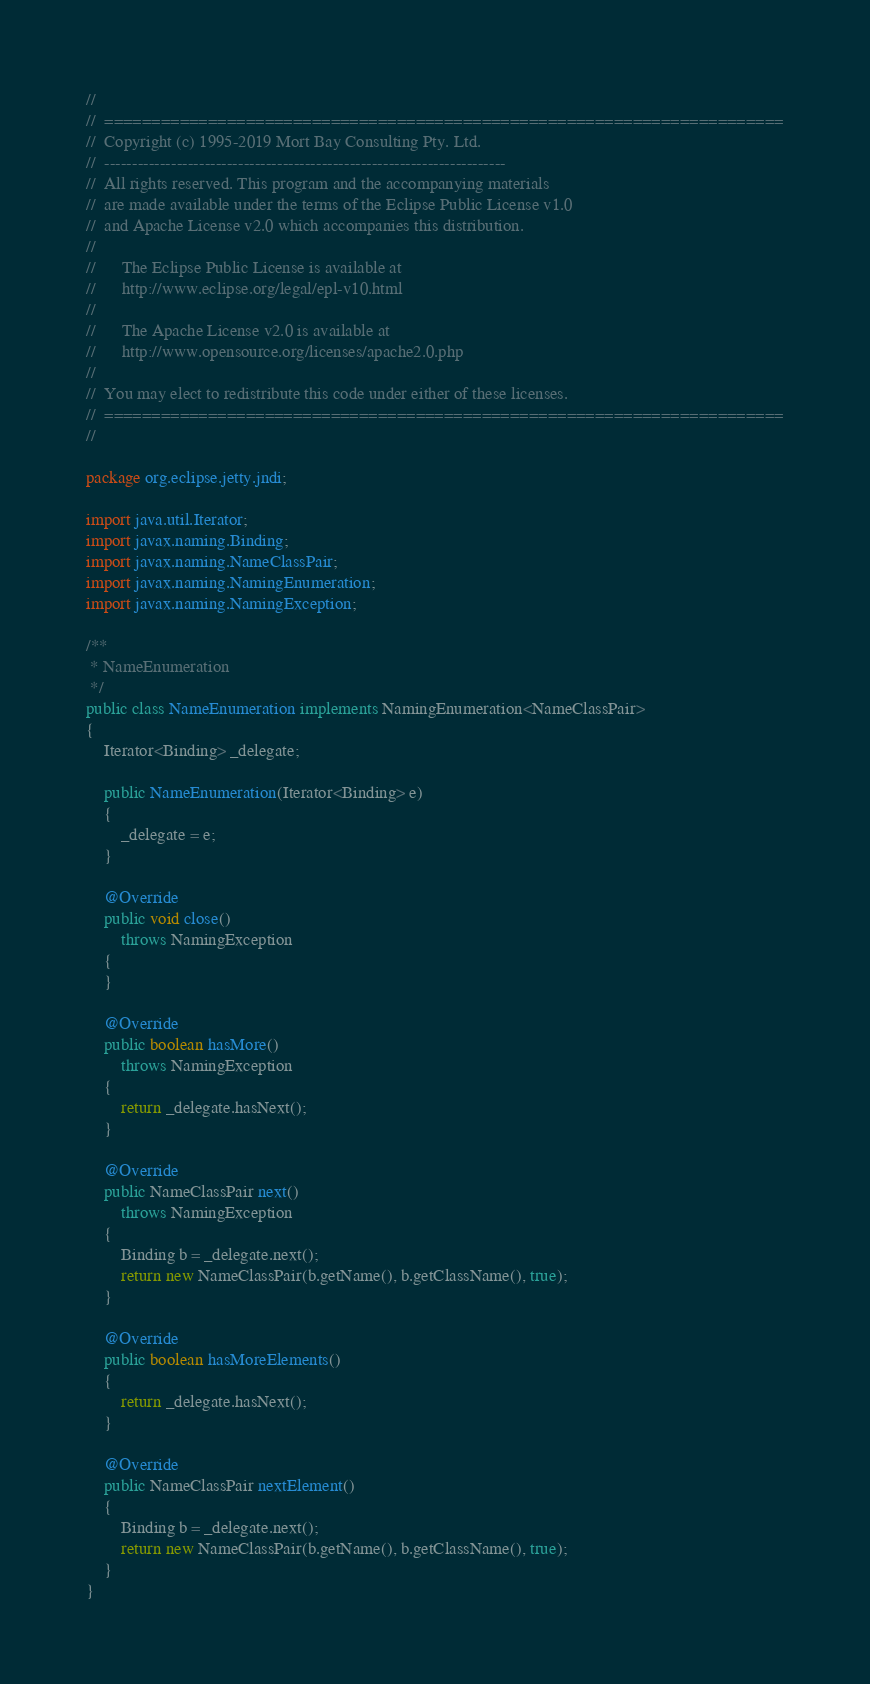Convert code to text. <code><loc_0><loc_0><loc_500><loc_500><_Java_>//
//  ========================================================================
//  Copyright (c) 1995-2019 Mort Bay Consulting Pty. Ltd.
//  ------------------------------------------------------------------------
//  All rights reserved. This program and the accompanying materials
//  are made available under the terms of the Eclipse Public License v1.0
//  and Apache License v2.0 which accompanies this distribution.
//
//      The Eclipse Public License is available at
//      http://www.eclipse.org/legal/epl-v10.html
//
//      The Apache License v2.0 is available at
//      http://www.opensource.org/licenses/apache2.0.php
//
//  You may elect to redistribute this code under either of these licenses.
//  ========================================================================
//

package org.eclipse.jetty.jndi;

import java.util.Iterator;
import javax.naming.Binding;
import javax.naming.NameClassPair;
import javax.naming.NamingEnumeration;
import javax.naming.NamingException;

/**
 * NameEnumeration
 */
public class NameEnumeration implements NamingEnumeration<NameClassPair>
{
    Iterator<Binding> _delegate;

    public NameEnumeration(Iterator<Binding> e)
    {
        _delegate = e;
    }

    @Override
    public void close()
        throws NamingException
    {
    }

    @Override
    public boolean hasMore()
        throws NamingException
    {
        return _delegate.hasNext();
    }

    @Override
    public NameClassPair next()
        throws NamingException
    {
        Binding b = _delegate.next();
        return new NameClassPair(b.getName(), b.getClassName(), true);
    }

    @Override
    public boolean hasMoreElements()
    {
        return _delegate.hasNext();
    }

    @Override
    public NameClassPair nextElement()
    {
        Binding b = _delegate.next();
        return new NameClassPair(b.getName(), b.getClassName(), true);
    }
}
</code> 